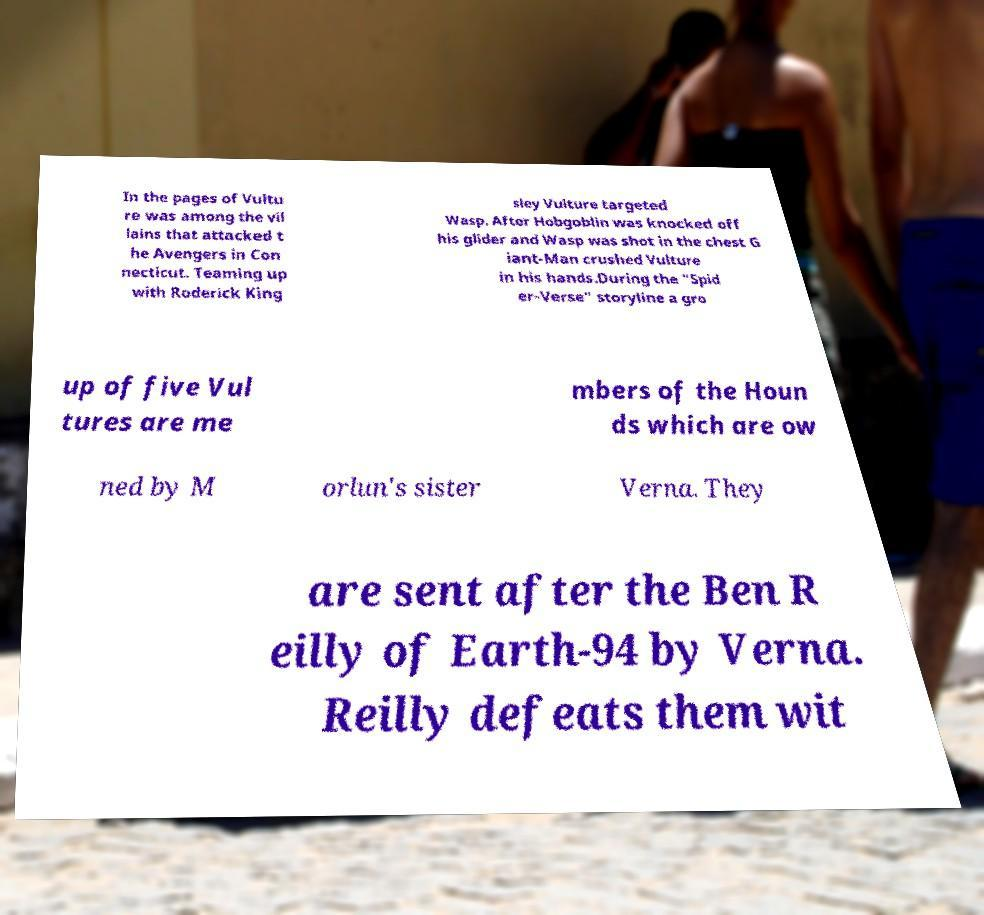Could you extract and type out the text from this image? In the pages of Vultu re was among the vil lains that attacked t he Avengers in Con necticut. Teaming up with Roderick King sley Vulture targeted Wasp. After Hobgoblin was knocked off his glider and Wasp was shot in the chest G iant-Man crushed Vulture in his hands.During the "Spid er-Verse" storyline a gro up of five Vul tures are me mbers of the Houn ds which are ow ned by M orlun's sister Verna. They are sent after the Ben R eilly of Earth-94 by Verna. Reilly defeats them wit 